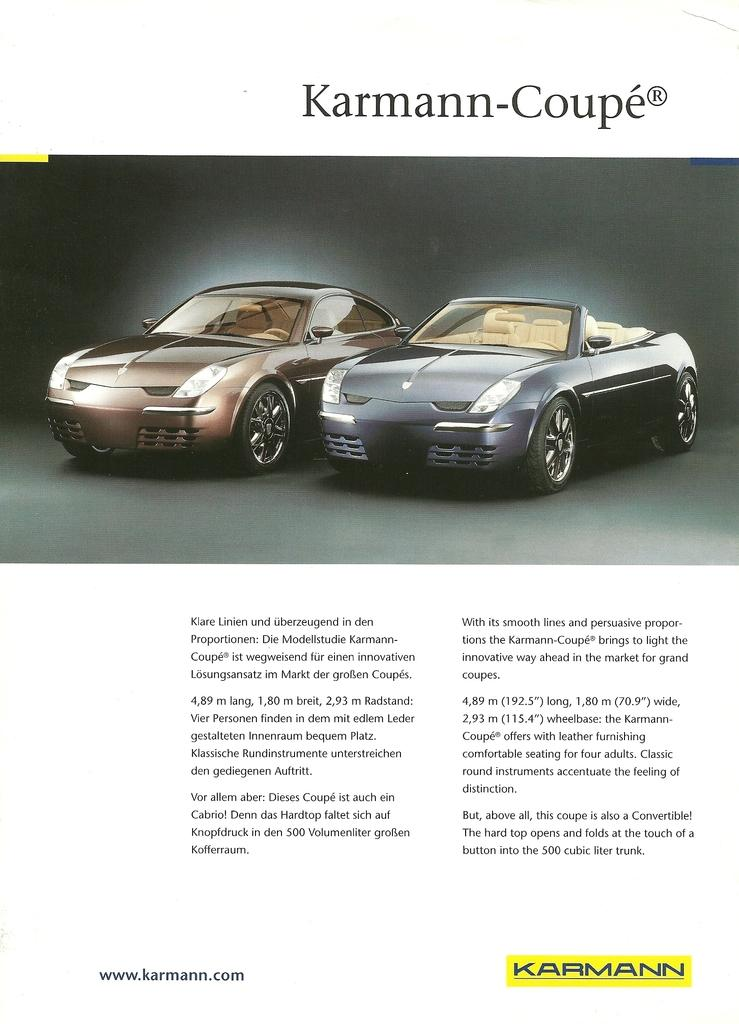How many cars are present in the image? There are two cars in the image. Can you describe the text written above and below the cars? Unfortunately, the facts provided do not give any information about the text written above and below the cars. What type of flame can be seen coming out of the exhaust of the cars in the image? There is no flame visible coming out of the exhaust of the cars in the image. 